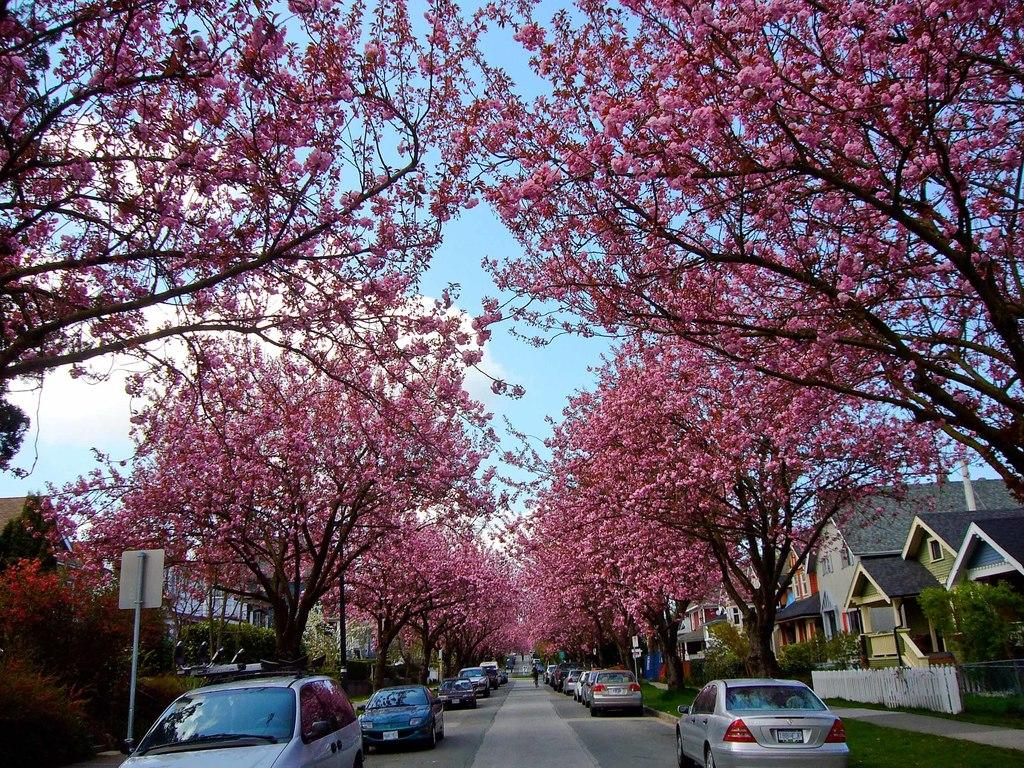What can be seen on the road in the image? There are cars on the road in the image. What is located on both sides of the road? Buildings and trees are present on both sides of the road. What else can be seen on both sides of the road? Poles are present on both sides of the road. What is visible in the background of the image? The sky is visible in the background of the image. What can be observed in the sky? There are clouds in the sky. What type of jam is being spread on the knife in the image? There is no jam or knife present in the image; it features cars on a road with buildings, trees, poles, and a sky with clouds. How many pins are visible on the road in the image? There are no pins visible on the road in the image. 